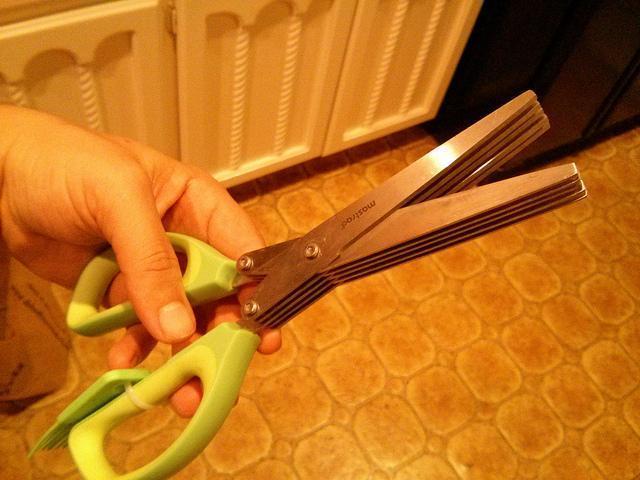How many dogs are in the image?
Give a very brief answer. 0. 